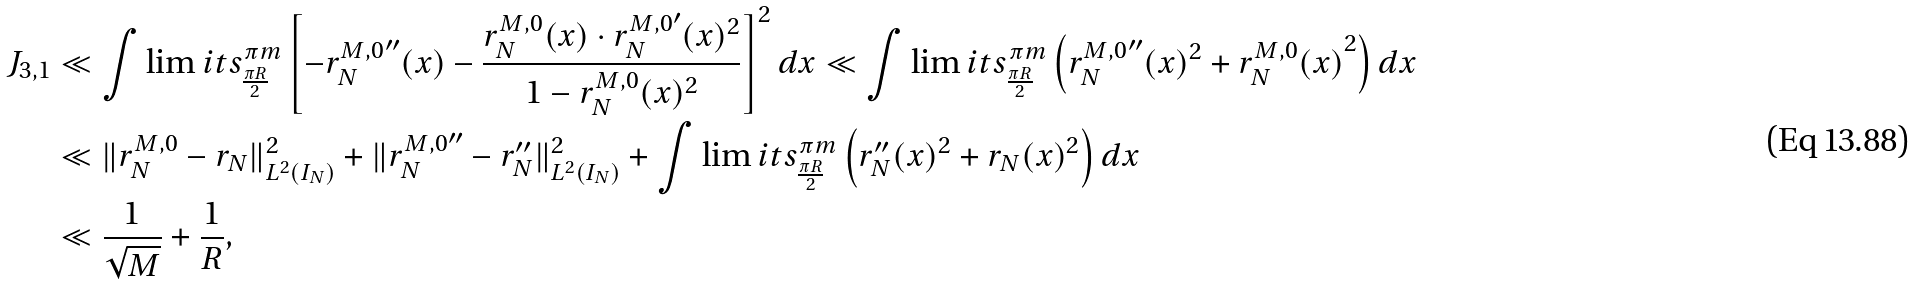Convert formula to latex. <formula><loc_0><loc_0><loc_500><loc_500>J _ { 3 , 1 } & \ll \int \lim i t s _ { \frac { \pi R } { 2 } } ^ { \pi m } \left [ { - r _ { N } ^ { M , 0 } } ^ { \prime \prime } ( x ) - \frac { r _ { N } ^ { M , 0 } ( x ) \cdot { r _ { N } ^ { M , 0 } } ^ { \prime } ( x ) ^ { 2 } } { 1 - r _ { N } ^ { M , 0 } ( x ) ^ { 2 } } \right ] ^ { 2 } d x \ll \int \lim i t s _ { \frac { \pi R } { 2 } } ^ { \pi m } \left ( { r _ { N } ^ { M , 0 } } ^ { \prime \prime } ( x ) ^ { 2 } + { r _ { N } ^ { M , 0 } ( x ) } ^ { 2 } \right ) d x \\ & \ll \| r _ { N } ^ { M , 0 } - r _ { N } \| _ { L ^ { 2 } ( I _ { N } ) } ^ { 2 } + \| { r _ { N } ^ { M , 0 } } ^ { \prime \prime } - r _ { N } ^ { \prime \prime } \| _ { L ^ { 2 } ( I _ { N } ) } ^ { 2 } + \int \lim i t s _ { \frac { \pi R } { 2 } } ^ { \pi m } \left ( r _ { N } ^ { \prime \prime } ( x ) ^ { 2 } + r _ { N } ( x ) ^ { 2 } \right ) d x \\ & \ll \frac { 1 } { \sqrt { M } } + \frac { 1 } { R } ,</formula> 